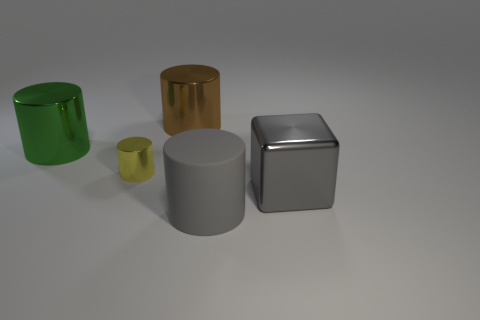Add 5 large green things. How many objects exist? 10 Subtract all cylinders. How many objects are left? 1 Add 1 big green cylinders. How many big green cylinders are left? 2 Add 3 small green rubber balls. How many small green rubber balls exist? 3 Subtract 1 gray cubes. How many objects are left? 4 Subtract all large metallic cylinders. Subtract all tiny blue metallic things. How many objects are left? 3 